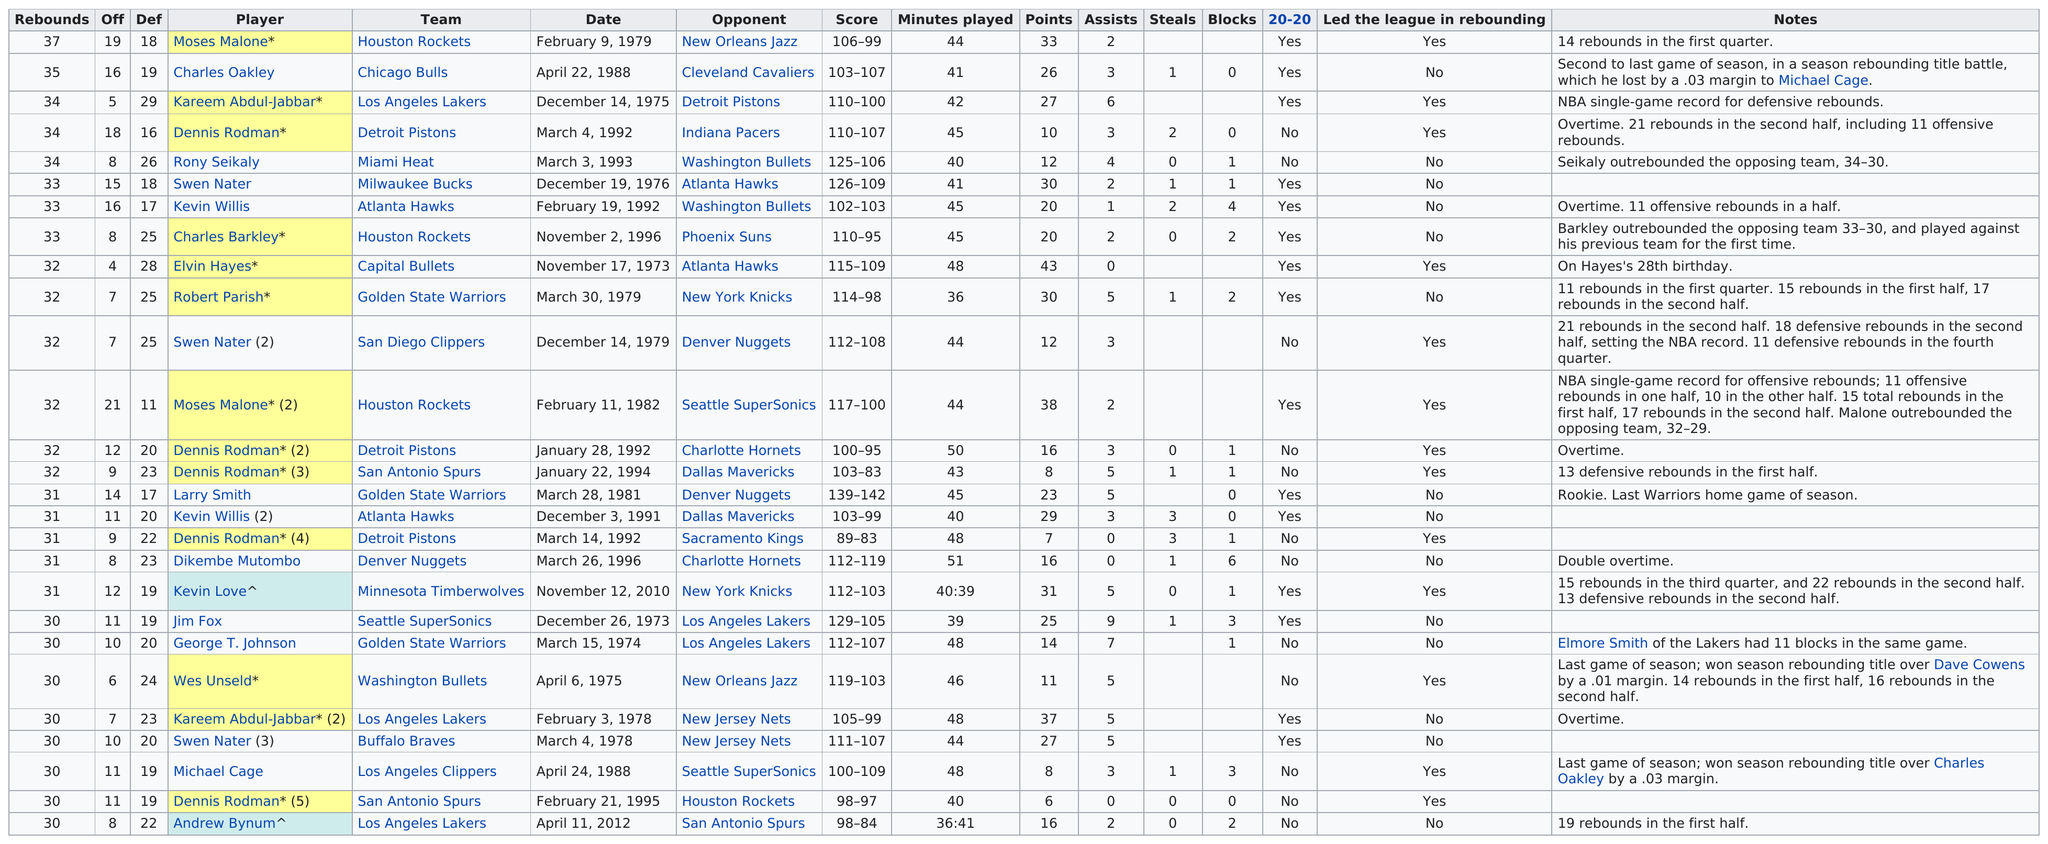Outline some significant characteristics in this image. In the game, several players tied for last place with a total of 30 rebounds. Eight players were involved in this tie. The difference between Dennis Rodman's and Robert Parish's offensive rebounds is 11. In 1979, were there more records set than in 1978? In 1978, the table shows that there were a total of 60 rebounds. The total number of rebounds accumulated by all Miami Heat players was 34. 